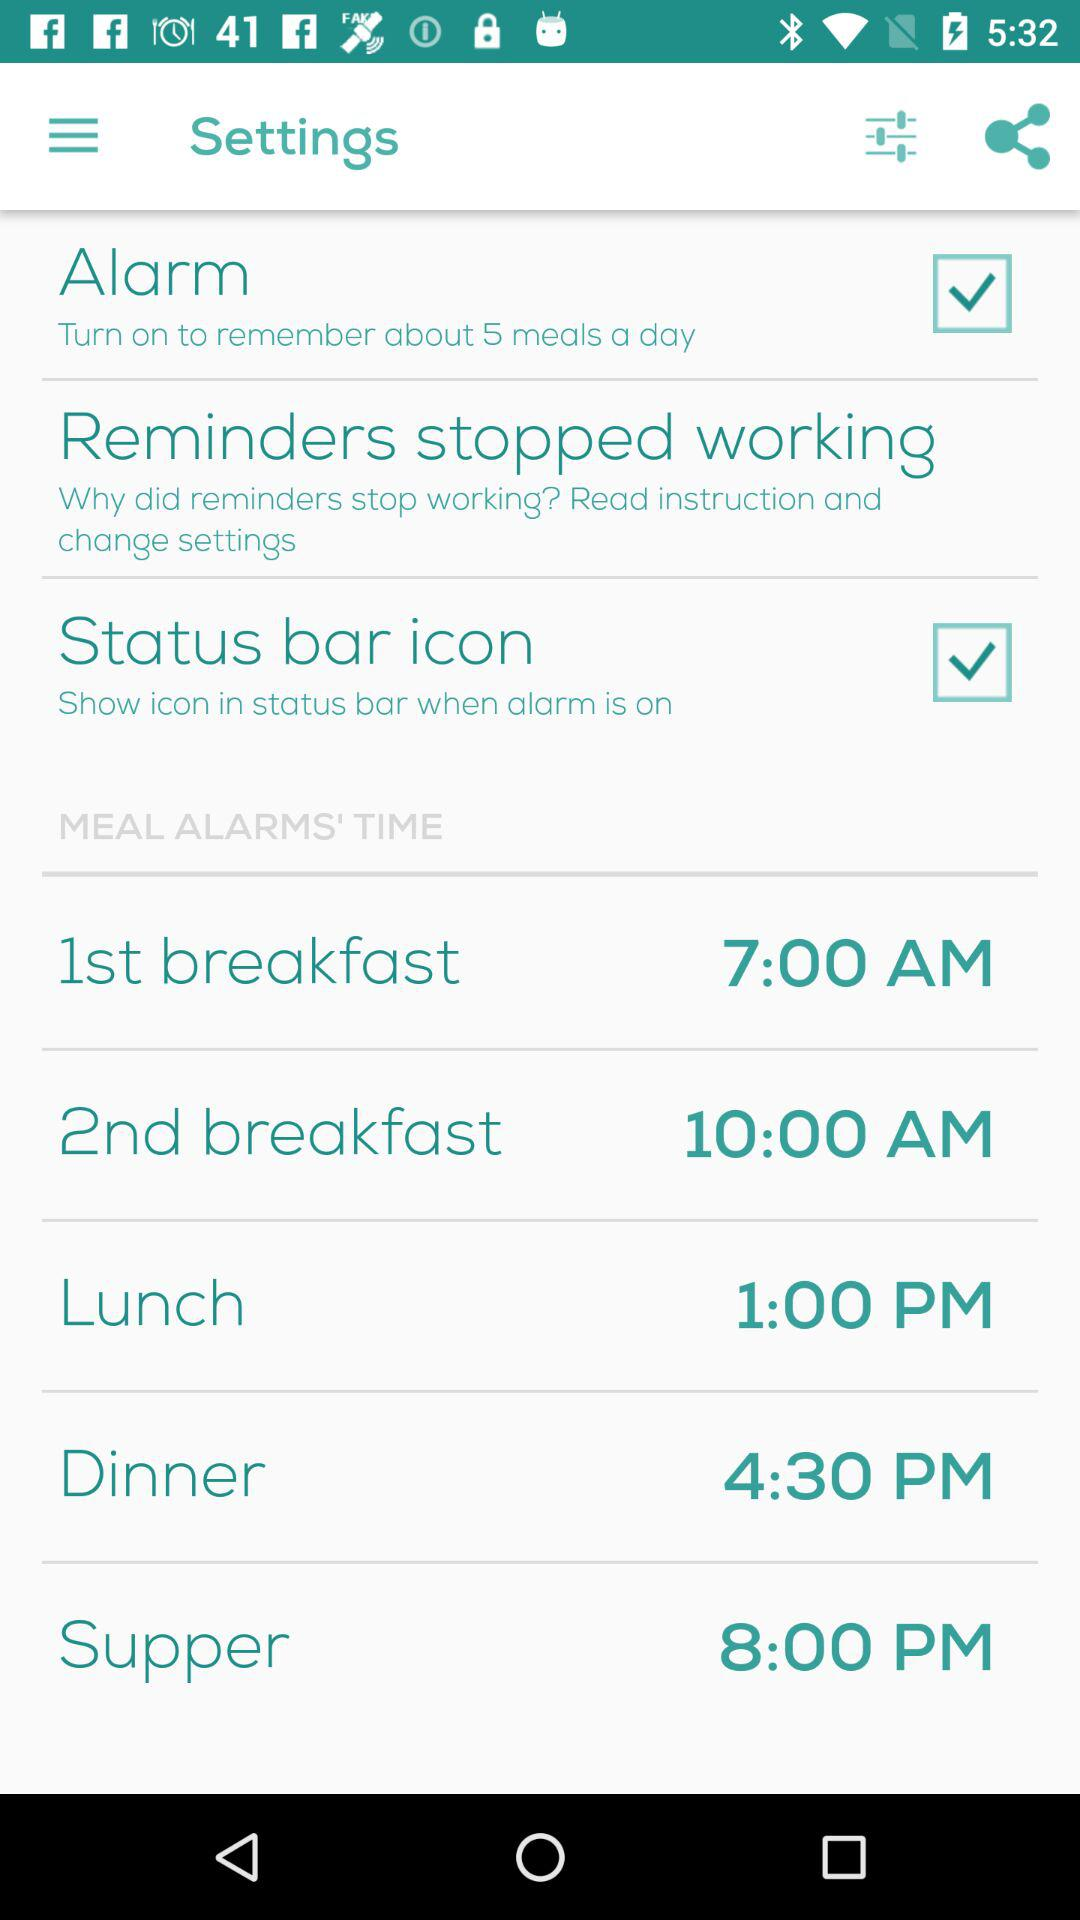Which alarm time is set for lunch? The alarm time set for lunch is 1:00 p.m. 